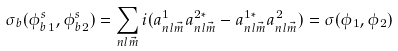<formula> <loc_0><loc_0><loc_500><loc_500>\sigma _ { b } ( { \phi _ { b } ^ { s } } _ { 1 } , { \phi _ { b } ^ { s } } _ { 2 } ) = \sum _ { n l \vec { m } } i ( a _ { n l \vec { m } } ^ { 1 } a _ { n l \vec { m } } ^ { 2 * } - a _ { n l \vec { m } } ^ { 1 * } a _ { n l \vec { m } } ^ { 2 } ) = \sigma ( { \phi } _ { 1 } , { \phi } _ { 2 } )</formula> 